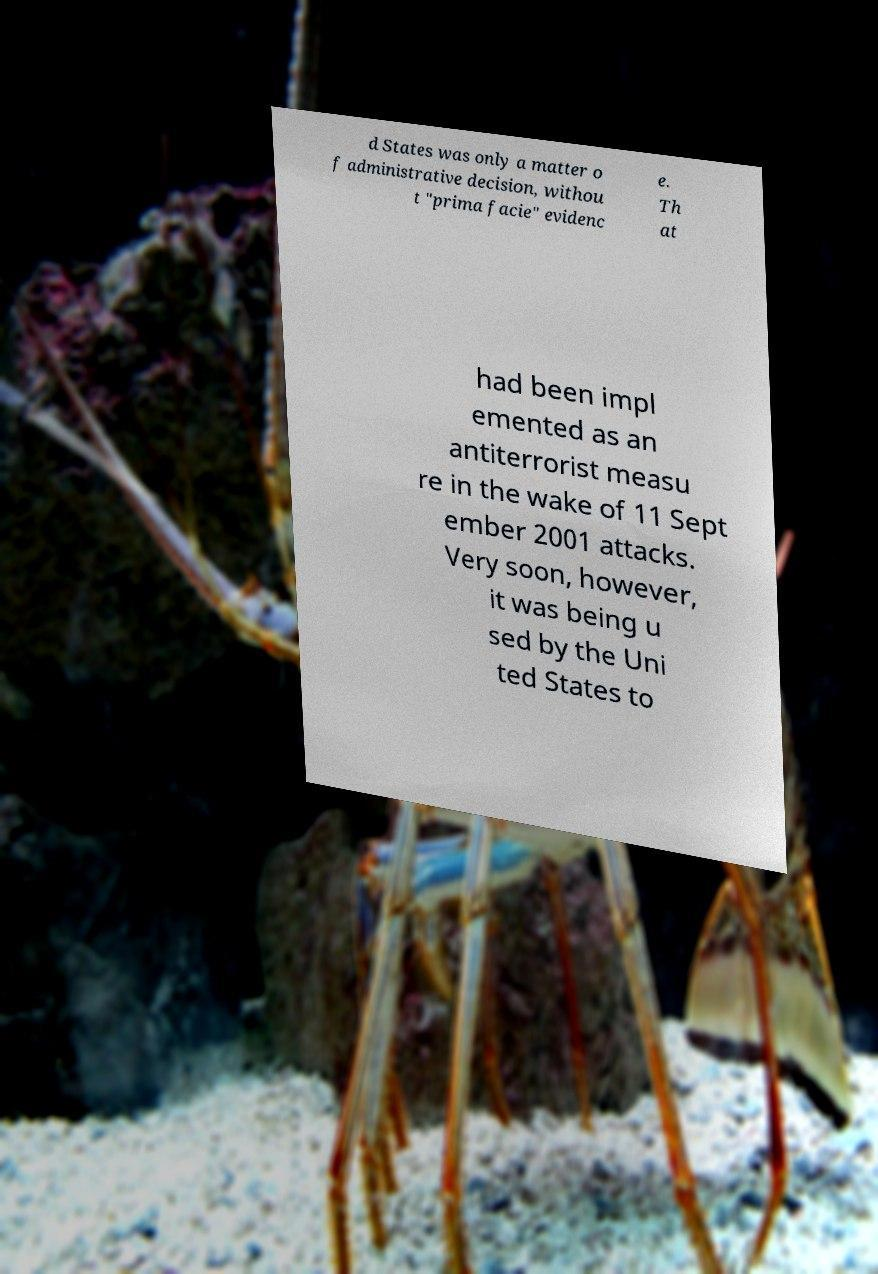Please read and relay the text visible in this image. What does it say? d States was only a matter o f administrative decision, withou t "prima facie" evidenc e. Th at had been impl emented as an antiterrorist measu re in the wake of 11 Sept ember 2001 attacks. Very soon, however, it was being u sed by the Uni ted States to 